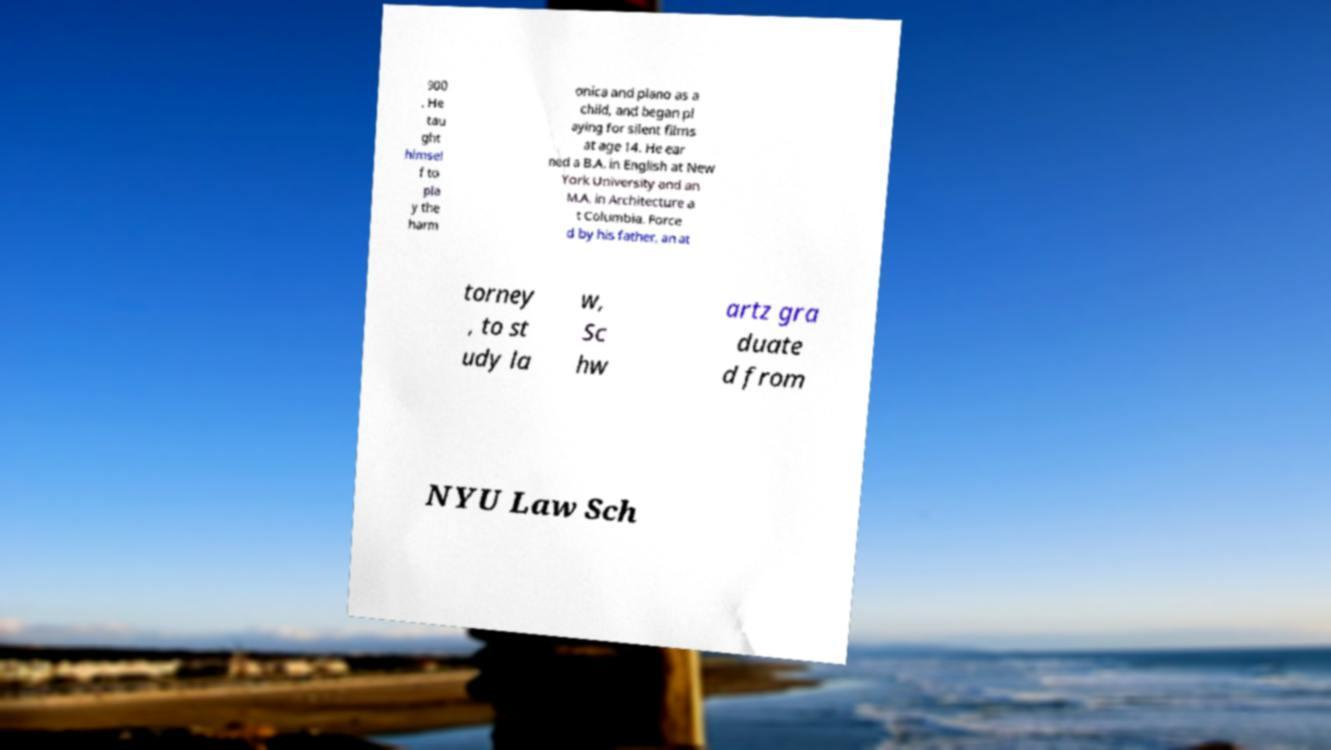Could you assist in decoding the text presented in this image and type it out clearly? 900 . He tau ght himsel f to pla y the harm onica and piano as a child, and began pl aying for silent films at age 14. He ear ned a B.A. in English at New York University and an M.A. in Architecture a t Columbia. Force d by his father, an at torney , to st udy la w, Sc hw artz gra duate d from NYU Law Sch 